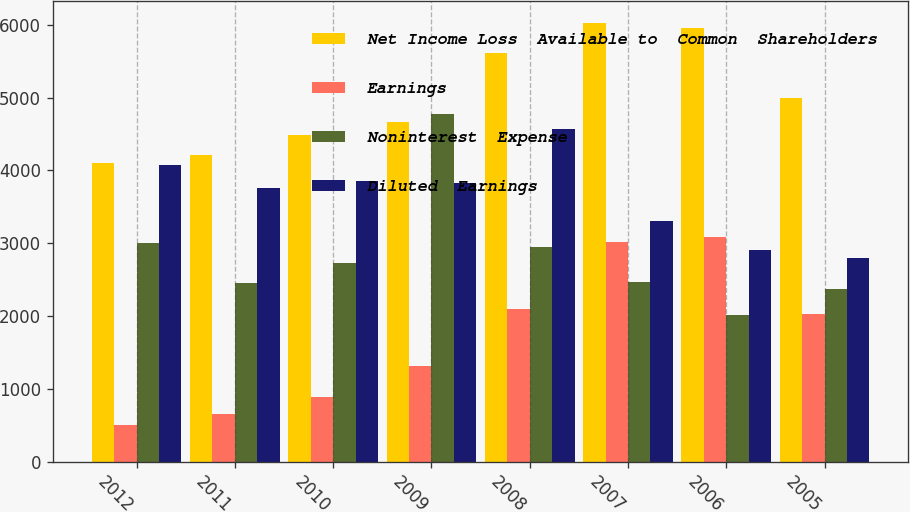<chart> <loc_0><loc_0><loc_500><loc_500><stacked_bar_chart><ecel><fcel>2012<fcel>2011<fcel>2010<fcel>2009<fcel>2008<fcel>2007<fcel>2006<fcel>2005<nl><fcel>Net Income Loss  Available to  Common  Shareholders<fcel>4107<fcel>4218<fcel>4489<fcel>4668<fcel>5608<fcel>6027<fcel>5955<fcel>4995<nl><fcel>Earnings<fcel>512<fcel>661<fcel>885<fcel>1314<fcel>2094<fcel>3018<fcel>3082<fcel>2030<nl><fcel>Noninterest  Expense<fcel>2999<fcel>2455<fcel>2729<fcel>4782<fcel>2946<fcel>2467<fcel>2012<fcel>2374<nl><fcel>Diluted  Earnings<fcel>4081<fcel>3758<fcel>3855<fcel>3826<fcel>4564<fcel>3311<fcel>2915<fcel>2801<nl></chart> 